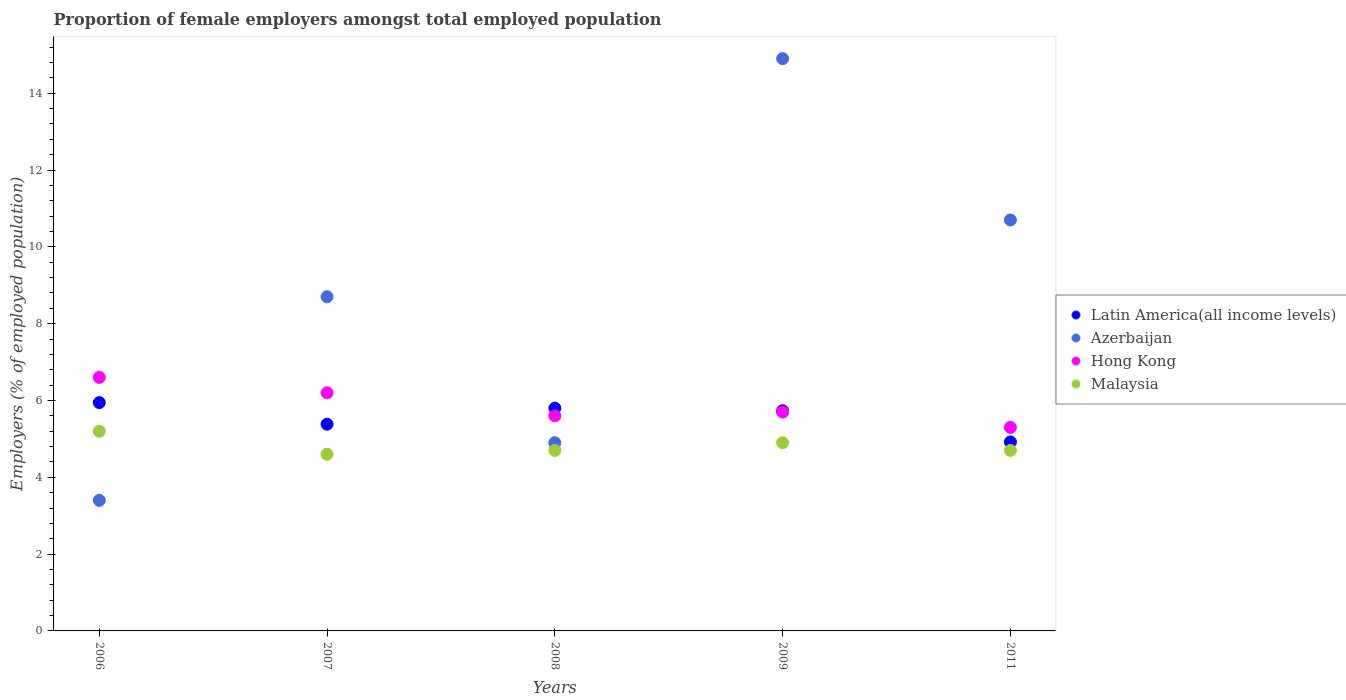How many different coloured dotlines are there?
Offer a terse response. 4. Is the number of dotlines equal to the number of legend labels?
Keep it short and to the point. Yes. What is the proportion of female employers in Azerbaijan in 2009?
Offer a terse response. 14.9. Across all years, what is the maximum proportion of female employers in Latin America(all income levels)?
Keep it short and to the point. 5.95. Across all years, what is the minimum proportion of female employers in Malaysia?
Keep it short and to the point. 4.6. In which year was the proportion of female employers in Latin America(all income levels) maximum?
Your response must be concise. 2006. What is the total proportion of female employers in Hong Kong in the graph?
Offer a very short reply. 29.4. What is the difference between the proportion of female employers in Malaysia in 2006 and that in 2008?
Ensure brevity in your answer.  0.5. What is the difference between the proportion of female employers in Malaysia in 2011 and the proportion of female employers in Hong Kong in 2008?
Offer a very short reply. -0.9. What is the average proportion of female employers in Latin America(all income levels) per year?
Keep it short and to the point. 5.56. In the year 2009, what is the difference between the proportion of female employers in Azerbaijan and proportion of female employers in Latin America(all income levels)?
Provide a short and direct response. 9.17. In how many years, is the proportion of female employers in Malaysia greater than 1.2000000000000002 %?
Keep it short and to the point. 5. What is the ratio of the proportion of female employers in Hong Kong in 2006 to that in 2011?
Offer a very short reply. 1.25. Is the proportion of female employers in Latin America(all income levels) in 2006 less than that in 2007?
Offer a terse response. No. What is the difference between the highest and the second highest proportion of female employers in Azerbaijan?
Offer a terse response. 4.2. What is the difference between the highest and the lowest proportion of female employers in Azerbaijan?
Provide a short and direct response. 11.5. In how many years, is the proportion of female employers in Hong Kong greater than the average proportion of female employers in Hong Kong taken over all years?
Your response must be concise. 2. Is the proportion of female employers in Malaysia strictly greater than the proportion of female employers in Azerbaijan over the years?
Offer a terse response. No. How many years are there in the graph?
Offer a terse response. 5. Does the graph contain any zero values?
Your answer should be very brief. No. Does the graph contain grids?
Make the answer very short. No. Where does the legend appear in the graph?
Provide a succinct answer. Center right. What is the title of the graph?
Offer a very short reply. Proportion of female employers amongst total employed population. Does "Australia" appear as one of the legend labels in the graph?
Give a very brief answer. No. What is the label or title of the X-axis?
Make the answer very short. Years. What is the label or title of the Y-axis?
Provide a succinct answer. Employers (% of employed population). What is the Employers (% of employed population) of Latin America(all income levels) in 2006?
Your answer should be compact. 5.95. What is the Employers (% of employed population) of Azerbaijan in 2006?
Your answer should be compact. 3.4. What is the Employers (% of employed population) of Hong Kong in 2006?
Your answer should be very brief. 6.6. What is the Employers (% of employed population) in Malaysia in 2006?
Give a very brief answer. 5.2. What is the Employers (% of employed population) of Latin America(all income levels) in 2007?
Your answer should be very brief. 5.38. What is the Employers (% of employed population) in Azerbaijan in 2007?
Your response must be concise. 8.7. What is the Employers (% of employed population) in Hong Kong in 2007?
Give a very brief answer. 6.2. What is the Employers (% of employed population) of Malaysia in 2007?
Provide a short and direct response. 4.6. What is the Employers (% of employed population) of Latin America(all income levels) in 2008?
Your response must be concise. 5.8. What is the Employers (% of employed population) in Azerbaijan in 2008?
Keep it short and to the point. 4.9. What is the Employers (% of employed population) of Hong Kong in 2008?
Make the answer very short. 5.6. What is the Employers (% of employed population) of Malaysia in 2008?
Ensure brevity in your answer.  4.7. What is the Employers (% of employed population) in Latin America(all income levels) in 2009?
Your response must be concise. 5.73. What is the Employers (% of employed population) of Azerbaijan in 2009?
Provide a succinct answer. 14.9. What is the Employers (% of employed population) in Hong Kong in 2009?
Provide a succinct answer. 5.7. What is the Employers (% of employed population) of Malaysia in 2009?
Your response must be concise. 4.9. What is the Employers (% of employed population) in Latin America(all income levels) in 2011?
Provide a short and direct response. 4.92. What is the Employers (% of employed population) of Azerbaijan in 2011?
Make the answer very short. 10.7. What is the Employers (% of employed population) in Hong Kong in 2011?
Ensure brevity in your answer.  5.3. What is the Employers (% of employed population) of Malaysia in 2011?
Provide a succinct answer. 4.7. Across all years, what is the maximum Employers (% of employed population) in Latin America(all income levels)?
Provide a short and direct response. 5.95. Across all years, what is the maximum Employers (% of employed population) in Azerbaijan?
Your answer should be very brief. 14.9. Across all years, what is the maximum Employers (% of employed population) in Hong Kong?
Ensure brevity in your answer.  6.6. Across all years, what is the maximum Employers (% of employed population) in Malaysia?
Offer a terse response. 5.2. Across all years, what is the minimum Employers (% of employed population) in Latin America(all income levels)?
Your answer should be very brief. 4.92. Across all years, what is the minimum Employers (% of employed population) in Azerbaijan?
Provide a succinct answer. 3.4. Across all years, what is the minimum Employers (% of employed population) in Hong Kong?
Make the answer very short. 5.3. Across all years, what is the minimum Employers (% of employed population) in Malaysia?
Provide a short and direct response. 4.6. What is the total Employers (% of employed population) of Latin America(all income levels) in the graph?
Offer a terse response. 27.78. What is the total Employers (% of employed population) of Azerbaijan in the graph?
Keep it short and to the point. 42.6. What is the total Employers (% of employed population) of Hong Kong in the graph?
Your response must be concise. 29.4. What is the total Employers (% of employed population) in Malaysia in the graph?
Provide a succinct answer. 24.1. What is the difference between the Employers (% of employed population) of Latin America(all income levels) in 2006 and that in 2007?
Ensure brevity in your answer.  0.56. What is the difference between the Employers (% of employed population) in Hong Kong in 2006 and that in 2007?
Make the answer very short. 0.4. What is the difference between the Employers (% of employed population) in Malaysia in 2006 and that in 2007?
Provide a short and direct response. 0.6. What is the difference between the Employers (% of employed population) in Latin America(all income levels) in 2006 and that in 2008?
Offer a terse response. 0.14. What is the difference between the Employers (% of employed population) of Azerbaijan in 2006 and that in 2008?
Ensure brevity in your answer.  -1.5. What is the difference between the Employers (% of employed population) of Hong Kong in 2006 and that in 2008?
Give a very brief answer. 1. What is the difference between the Employers (% of employed population) of Malaysia in 2006 and that in 2008?
Offer a terse response. 0.5. What is the difference between the Employers (% of employed population) of Latin America(all income levels) in 2006 and that in 2009?
Your answer should be compact. 0.21. What is the difference between the Employers (% of employed population) of Azerbaijan in 2006 and that in 2009?
Your answer should be very brief. -11.5. What is the difference between the Employers (% of employed population) in Hong Kong in 2006 and that in 2009?
Your response must be concise. 0.9. What is the difference between the Employers (% of employed population) of Latin America(all income levels) in 2006 and that in 2011?
Keep it short and to the point. 1.02. What is the difference between the Employers (% of employed population) in Azerbaijan in 2006 and that in 2011?
Provide a short and direct response. -7.3. What is the difference between the Employers (% of employed population) in Hong Kong in 2006 and that in 2011?
Provide a short and direct response. 1.3. What is the difference between the Employers (% of employed population) of Latin America(all income levels) in 2007 and that in 2008?
Ensure brevity in your answer.  -0.42. What is the difference between the Employers (% of employed population) in Azerbaijan in 2007 and that in 2008?
Give a very brief answer. 3.8. What is the difference between the Employers (% of employed population) of Malaysia in 2007 and that in 2008?
Keep it short and to the point. -0.1. What is the difference between the Employers (% of employed population) of Latin America(all income levels) in 2007 and that in 2009?
Your answer should be compact. -0.35. What is the difference between the Employers (% of employed population) in Hong Kong in 2007 and that in 2009?
Your response must be concise. 0.5. What is the difference between the Employers (% of employed population) of Latin America(all income levels) in 2007 and that in 2011?
Offer a very short reply. 0.46. What is the difference between the Employers (% of employed population) of Malaysia in 2007 and that in 2011?
Your response must be concise. -0.1. What is the difference between the Employers (% of employed population) of Latin America(all income levels) in 2008 and that in 2009?
Ensure brevity in your answer.  0.07. What is the difference between the Employers (% of employed population) of Hong Kong in 2008 and that in 2009?
Offer a terse response. -0.1. What is the difference between the Employers (% of employed population) of Latin America(all income levels) in 2008 and that in 2011?
Ensure brevity in your answer.  0.88. What is the difference between the Employers (% of employed population) in Malaysia in 2008 and that in 2011?
Give a very brief answer. 0. What is the difference between the Employers (% of employed population) of Latin America(all income levels) in 2009 and that in 2011?
Offer a terse response. 0.81. What is the difference between the Employers (% of employed population) in Azerbaijan in 2009 and that in 2011?
Ensure brevity in your answer.  4.2. What is the difference between the Employers (% of employed population) in Hong Kong in 2009 and that in 2011?
Provide a succinct answer. 0.4. What is the difference between the Employers (% of employed population) in Latin America(all income levels) in 2006 and the Employers (% of employed population) in Azerbaijan in 2007?
Ensure brevity in your answer.  -2.75. What is the difference between the Employers (% of employed population) of Latin America(all income levels) in 2006 and the Employers (% of employed population) of Hong Kong in 2007?
Your answer should be compact. -0.25. What is the difference between the Employers (% of employed population) of Latin America(all income levels) in 2006 and the Employers (% of employed population) of Malaysia in 2007?
Offer a terse response. 1.35. What is the difference between the Employers (% of employed population) in Azerbaijan in 2006 and the Employers (% of employed population) in Malaysia in 2007?
Ensure brevity in your answer.  -1.2. What is the difference between the Employers (% of employed population) of Hong Kong in 2006 and the Employers (% of employed population) of Malaysia in 2007?
Your answer should be very brief. 2. What is the difference between the Employers (% of employed population) in Latin America(all income levels) in 2006 and the Employers (% of employed population) in Azerbaijan in 2008?
Make the answer very short. 1.05. What is the difference between the Employers (% of employed population) of Latin America(all income levels) in 2006 and the Employers (% of employed population) of Hong Kong in 2008?
Give a very brief answer. 0.35. What is the difference between the Employers (% of employed population) of Latin America(all income levels) in 2006 and the Employers (% of employed population) of Malaysia in 2008?
Keep it short and to the point. 1.25. What is the difference between the Employers (% of employed population) in Azerbaijan in 2006 and the Employers (% of employed population) in Malaysia in 2008?
Give a very brief answer. -1.3. What is the difference between the Employers (% of employed population) in Hong Kong in 2006 and the Employers (% of employed population) in Malaysia in 2008?
Offer a terse response. 1.9. What is the difference between the Employers (% of employed population) in Latin America(all income levels) in 2006 and the Employers (% of employed population) in Azerbaijan in 2009?
Keep it short and to the point. -8.95. What is the difference between the Employers (% of employed population) of Latin America(all income levels) in 2006 and the Employers (% of employed population) of Hong Kong in 2009?
Your response must be concise. 0.25. What is the difference between the Employers (% of employed population) in Latin America(all income levels) in 2006 and the Employers (% of employed population) in Malaysia in 2009?
Offer a terse response. 1.05. What is the difference between the Employers (% of employed population) in Azerbaijan in 2006 and the Employers (% of employed population) in Malaysia in 2009?
Your answer should be very brief. -1.5. What is the difference between the Employers (% of employed population) of Hong Kong in 2006 and the Employers (% of employed population) of Malaysia in 2009?
Make the answer very short. 1.7. What is the difference between the Employers (% of employed population) of Latin America(all income levels) in 2006 and the Employers (% of employed population) of Azerbaijan in 2011?
Give a very brief answer. -4.75. What is the difference between the Employers (% of employed population) in Latin America(all income levels) in 2006 and the Employers (% of employed population) in Hong Kong in 2011?
Your answer should be compact. 0.65. What is the difference between the Employers (% of employed population) of Latin America(all income levels) in 2006 and the Employers (% of employed population) of Malaysia in 2011?
Provide a succinct answer. 1.25. What is the difference between the Employers (% of employed population) in Azerbaijan in 2006 and the Employers (% of employed population) in Hong Kong in 2011?
Ensure brevity in your answer.  -1.9. What is the difference between the Employers (% of employed population) of Azerbaijan in 2006 and the Employers (% of employed population) of Malaysia in 2011?
Give a very brief answer. -1.3. What is the difference between the Employers (% of employed population) in Hong Kong in 2006 and the Employers (% of employed population) in Malaysia in 2011?
Your answer should be very brief. 1.9. What is the difference between the Employers (% of employed population) of Latin America(all income levels) in 2007 and the Employers (% of employed population) of Azerbaijan in 2008?
Provide a short and direct response. 0.48. What is the difference between the Employers (% of employed population) of Latin America(all income levels) in 2007 and the Employers (% of employed population) of Hong Kong in 2008?
Keep it short and to the point. -0.22. What is the difference between the Employers (% of employed population) in Latin America(all income levels) in 2007 and the Employers (% of employed population) in Malaysia in 2008?
Your response must be concise. 0.68. What is the difference between the Employers (% of employed population) of Azerbaijan in 2007 and the Employers (% of employed population) of Malaysia in 2008?
Offer a very short reply. 4. What is the difference between the Employers (% of employed population) in Hong Kong in 2007 and the Employers (% of employed population) in Malaysia in 2008?
Offer a terse response. 1.5. What is the difference between the Employers (% of employed population) in Latin America(all income levels) in 2007 and the Employers (% of employed population) in Azerbaijan in 2009?
Your answer should be very brief. -9.52. What is the difference between the Employers (% of employed population) in Latin America(all income levels) in 2007 and the Employers (% of employed population) in Hong Kong in 2009?
Your answer should be compact. -0.32. What is the difference between the Employers (% of employed population) of Latin America(all income levels) in 2007 and the Employers (% of employed population) of Malaysia in 2009?
Ensure brevity in your answer.  0.48. What is the difference between the Employers (% of employed population) in Azerbaijan in 2007 and the Employers (% of employed population) in Hong Kong in 2009?
Your answer should be compact. 3. What is the difference between the Employers (% of employed population) in Latin America(all income levels) in 2007 and the Employers (% of employed population) in Azerbaijan in 2011?
Provide a succinct answer. -5.32. What is the difference between the Employers (% of employed population) in Latin America(all income levels) in 2007 and the Employers (% of employed population) in Hong Kong in 2011?
Give a very brief answer. 0.08. What is the difference between the Employers (% of employed population) in Latin America(all income levels) in 2007 and the Employers (% of employed population) in Malaysia in 2011?
Provide a short and direct response. 0.68. What is the difference between the Employers (% of employed population) in Azerbaijan in 2007 and the Employers (% of employed population) in Hong Kong in 2011?
Offer a terse response. 3.4. What is the difference between the Employers (% of employed population) in Azerbaijan in 2007 and the Employers (% of employed population) in Malaysia in 2011?
Make the answer very short. 4. What is the difference between the Employers (% of employed population) of Hong Kong in 2007 and the Employers (% of employed population) of Malaysia in 2011?
Ensure brevity in your answer.  1.5. What is the difference between the Employers (% of employed population) of Latin America(all income levels) in 2008 and the Employers (% of employed population) of Azerbaijan in 2009?
Your answer should be compact. -9.1. What is the difference between the Employers (% of employed population) in Latin America(all income levels) in 2008 and the Employers (% of employed population) in Hong Kong in 2009?
Your response must be concise. 0.1. What is the difference between the Employers (% of employed population) in Latin America(all income levels) in 2008 and the Employers (% of employed population) in Malaysia in 2009?
Your answer should be compact. 0.9. What is the difference between the Employers (% of employed population) in Azerbaijan in 2008 and the Employers (% of employed population) in Hong Kong in 2009?
Provide a succinct answer. -0.8. What is the difference between the Employers (% of employed population) in Azerbaijan in 2008 and the Employers (% of employed population) in Malaysia in 2009?
Ensure brevity in your answer.  0. What is the difference between the Employers (% of employed population) of Hong Kong in 2008 and the Employers (% of employed population) of Malaysia in 2009?
Offer a very short reply. 0.7. What is the difference between the Employers (% of employed population) of Latin America(all income levels) in 2008 and the Employers (% of employed population) of Azerbaijan in 2011?
Offer a terse response. -4.9. What is the difference between the Employers (% of employed population) of Latin America(all income levels) in 2008 and the Employers (% of employed population) of Hong Kong in 2011?
Ensure brevity in your answer.  0.5. What is the difference between the Employers (% of employed population) of Latin America(all income levels) in 2008 and the Employers (% of employed population) of Malaysia in 2011?
Your answer should be compact. 1.1. What is the difference between the Employers (% of employed population) of Azerbaijan in 2008 and the Employers (% of employed population) of Hong Kong in 2011?
Offer a terse response. -0.4. What is the difference between the Employers (% of employed population) of Azerbaijan in 2008 and the Employers (% of employed population) of Malaysia in 2011?
Your answer should be very brief. 0.2. What is the difference between the Employers (% of employed population) of Hong Kong in 2008 and the Employers (% of employed population) of Malaysia in 2011?
Offer a very short reply. 0.9. What is the difference between the Employers (% of employed population) of Latin America(all income levels) in 2009 and the Employers (% of employed population) of Azerbaijan in 2011?
Give a very brief answer. -4.97. What is the difference between the Employers (% of employed population) in Latin America(all income levels) in 2009 and the Employers (% of employed population) in Hong Kong in 2011?
Give a very brief answer. 0.43. What is the difference between the Employers (% of employed population) of Latin America(all income levels) in 2009 and the Employers (% of employed population) of Malaysia in 2011?
Offer a terse response. 1.03. What is the difference between the Employers (% of employed population) of Azerbaijan in 2009 and the Employers (% of employed population) of Hong Kong in 2011?
Give a very brief answer. 9.6. What is the difference between the Employers (% of employed population) of Hong Kong in 2009 and the Employers (% of employed population) of Malaysia in 2011?
Your answer should be compact. 1. What is the average Employers (% of employed population) of Latin America(all income levels) per year?
Give a very brief answer. 5.56. What is the average Employers (% of employed population) in Azerbaijan per year?
Offer a very short reply. 8.52. What is the average Employers (% of employed population) in Hong Kong per year?
Your answer should be very brief. 5.88. What is the average Employers (% of employed population) in Malaysia per year?
Your answer should be compact. 4.82. In the year 2006, what is the difference between the Employers (% of employed population) of Latin America(all income levels) and Employers (% of employed population) of Azerbaijan?
Provide a succinct answer. 2.55. In the year 2006, what is the difference between the Employers (% of employed population) of Latin America(all income levels) and Employers (% of employed population) of Hong Kong?
Give a very brief answer. -0.65. In the year 2006, what is the difference between the Employers (% of employed population) in Latin America(all income levels) and Employers (% of employed population) in Malaysia?
Ensure brevity in your answer.  0.75. In the year 2006, what is the difference between the Employers (% of employed population) of Azerbaijan and Employers (% of employed population) of Hong Kong?
Keep it short and to the point. -3.2. In the year 2006, what is the difference between the Employers (% of employed population) of Azerbaijan and Employers (% of employed population) of Malaysia?
Your response must be concise. -1.8. In the year 2006, what is the difference between the Employers (% of employed population) of Hong Kong and Employers (% of employed population) of Malaysia?
Your answer should be very brief. 1.4. In the year 2007, what is the difference between the Employers (% of employed population) of Latin America(all income levels) and Employers (% of employed population) of Azerbaijan?
Make the answer very short. -3.32. In the year 2007, what is the difference between the Employers (% of employed population) in Latin America(all income levels) and Employers (% of employed population) in Hong Kong?
Keep it short and to the point. -0.82. In the year 2007, what is the difference between the Employers (% of employed population) in Latin America(all income levels) and Employers (% of employed population) in Malaysia?
Keep it short and to the point. 0.78. In the year 2008, what is the difference between the Employers (% of employed population) in Latin America(all income levels) and Employers (% of employed population) in Azerbaijan?
Offer a terse response. 0.9. In the year 2008, what is the difference between the Employers (% of employed population) in Latin America(all income levels) and Employers (% of employed population) in Hong Kong?
Keep it short and to the point. 0.2. In the year 2008, what is the difference between the Employers (% of employed population) in Latin America(all income levels) and Employers (% of employed population) in Malaysia?
Provide a short and direct response. 1.1. In the year 2008, what is the difference between the Employers (% of employed population) in Hong Kong and Employers (% of employed population) in Malaysia?
Keep it short and to the point. 0.9. In the year 2009, what is the difference between the Employers (% of employed population) of Latin America(all income levels) and Employers (% of employed population) of Azerbaijan?
Keep it short and to the point. -9.17. In the year 2009, what is the difference between the Employers (% of employed population) of Latin America(all income levels) and Employers (% of employed population) of Hong Kong?
Your answer should be compact. 0.03. In the year 2009, what is the difference between the Employers (% of employed population) in Latin America(all income levels) and Employers (% of employed population) in Malaysia?
Ensure brevity in your answer.  0.83. In the year 2009, what is the difference between the Employers (% of employed population) of Azerbaijan and Employers (% of employed population) of Malaysia?
Your answer should be compact. 10. In the year 2011, what is the difference between the Employers (% of employed population) of Latin America(all income levels) and Employers (% of employed population) of Azerbaijan?
Provide a short and direct response. -5.78. In the year 2011, what is the difference between the Employers (% of employed population) in Latin America(all income levels) and Employers (% of employed population) in Hong Kong?
Your response must be concise. -0.38. In the year 2011, what is the difference between the Employers (% of employed population) in Latin America(all income levels) and Employers (% of employed population) in Malaysia?
Your answer should be very brief. 0.22. In the year 2011, what is the difference between the Employers (% of employed population) of Azerbaijan and Employers (% of employed population) of Malaysia?
Your response must be concise. 6. What is the ratio of the Employers (% of employed population) of Latin America(all income levels) in 2006 to that in 2007?
Provide a short and direct response. 1.1. What is the ratio of the Employers (% of employed population) in Azerbaijan in 2006 to that in 2007?
Keep it short and to the point. 0.39. What is the ratio of the Employers (% of employed population) in Hong Kong in 2006 to that in 2007?
Make the answer very short. 1.06. What is the ratio of the Employers (% of employed population) of Malaysia in 2006 to that in 2007?
Make the answer very short. 1.13. What is the ratio of the Employers (% of employed population) in Latin America(all income levels) in 2006 to that in 2008?
Your response must be concise. 1.02. What is the ratio of the Employers (% of employed population) in Azerbaijan in 2006 to that in 2008?
Offer a terse response. 0.69. What is the ratio of the Employers (% of employed population) in Hong Kong in 2006 to that in 2008?
Offer a terse response. 1.18. What is the ratio of the Employers (% of employed population) in Malaysia in 2006 to that in 2008?
Provide a succinct answer. 1.11. What is the ratio of the Employers (% of employed population) of Latin America(all income levels) in 2006 to that in 2009?
Keep it short and to the point. 1.04. What is the ratio of the Employers (% of employed population) of Azerbaijan in 2006 to that in 2009?
Your response must be concise. 0.23. What is the ratio of the Employers (% of employed population) in Hong Kong in 2006 to that in 2009?
Provide a succinct answer. 1.16. What is the ratio of the Employers (% of employed population) of Malaysia in 2006 to that in 2009?
Your answer should be compact. 1.06. What is the ratio of the Employers (% of employed population) in Latin America(all income levels) in 2006 to that in 2011?
Your answer should be compact. 1.21. What is the ratio of the Employers (% of employed population) in Azerbaijan in 2006 to that in 2011?
Give a very brief answer. 0.32. What is the ratio of the Employers (% of employed population) of Hong Kong in 2006 to that in 2011?
Provide a short and direct response. 1.25. What is the ratio of the Employers (% of employed population) in Malaysia in 2006 to that in 2011?
Offer a very short reply. 1.11. What is the ratio of the Employers (% of employed population) in Latin America(all income levels) in 2007 to that in 2008?
Provide a succinct answer. 0.93. What is the ratio of the Employers (% of employed population) in Azerbaijan in 2007 to that in 2008?
Give a very brief answer. 1.78. What is the ratio of the Employers (% of employed population) of Hong Kong in 2007 to that in 2008?
Your answer should be compact. 1.11. What is the ratio of the Employers (% of employed population) of Malaysia in 2007 to that in 2008?
Provide a succinct answer. 0.98. What is the ratio of the Employers (% of employed population) of Latin America(all income levels) in 2007 to that in 2009?
Provide a succinct answer. 0.94. What is the ratio of the Employers (% of employed population) in Azerbaijan in 2007 to that in 2009?
Offer a terse response. 0.58. What is the ratio of the Employers (% of employed population) in Hong Kong in 2007 to that in 2009?
Your response must be concise. 1.09. What is the ratio of the Employers (% of employed population) in Malaysia in 2007 to that in 2009?
Your answer should be compact. 0.94. What is the ratio of the Employers (% of employed population) in Latin America(all income levels) in 2007 to that in 2011?
Offer a terse response. 1.09. What is the ratio of the Employers (% of employed population) in Azerbaijan in 2007 to that in 2011?
Keep it short and to the point. 0.81. What is the ratio of the Employers (% of employed population) of Hong Kong in 2007 to that in 2011?
Offer a very short reply. 1.17. What is the ratio of the Employers (% of employed population) in Malaysia in 2007 to that in 2011?
Your response must be concise. 0.98. What is the ratio of the Employers (% of employed population) of Latin America(all income levels) in 2008 to that in 2009?
Give a very brief answer. 1.01. What is the ratio of the Employers (% of employed population) in Azerbaijan in 2008 to that in 2009?
Keep it short and to the point. 0.33. What is the ratio of the Employers (% of employed population) in Hong Kong in 2008 to that in 2009?
Provide a succinct answer. 0.98. What is the ratio of the Employers (% of employed population) in Malaysia in 2008 to that in 2009?
Provide a succinct answer. 0.96. What is the ratio of the Employers (% of employed population) in Latin America(all income levels) in 2008 to that in 2011?
Give a very brief answer. 1.18. What is the ratio of the Employers (% of employed population) of Azerbaijan in 2008 to that in 2011?
Offer a very short reply. 0.46. What is the ratio of the Employers (% of employed population) of Hong Kong in 2008 to that in 2011?
Ensure brevity in your answer.  1.06. What is the ratio of the Employers (% of employed population) in Malaysia in 2008 to that in 2011?
Your answer should be very brief. 1. What is the ratio of the Employers (% of employed population) in Latin America(all income levels) in 2009 to that in 2011?
Your response must be concise. 1.17. What is the ratio of the Employers (% of employed population) in Azerbaijan in 2009 to that in 2011?
Make the answer very short. 1.39. What is the ratio of the Employers (% of employed population) of Hong Kong in 2009 to that in 2011?
Give a very brief answer. 1.08. What is the ratio of the Employers (% of employed population) in Malaysia in 2009 to that in 2011?
Keep it short and to the point. 1.04. What is the difference between the highest and the second highest Employers (% of employed population) of Latin America(all income levels)?
Offer a terse response. 0.14. What is the difference between the highest and the second highest Employers (% of employed population) of Azerbaijan?
Your response must be concise. 4.2. What is the difference between the highest and the second highest Employers (% of employed population) of Hong Kong?
Offer a very short reply. 0.4. What is the difference between the highest and the lowest Employers (% of employed population) in Latin America(all income levels)?
Give a very brief answer. 1.02. What is the difference between the highest and the lowest Employers (% of employed population) of Azerbaijan?
Make the answer very short. 11.5. What is the difference between the highest and the lowest Employers (% of employed population) of Hong Kong?
Your answer should be compact. 1.3. 